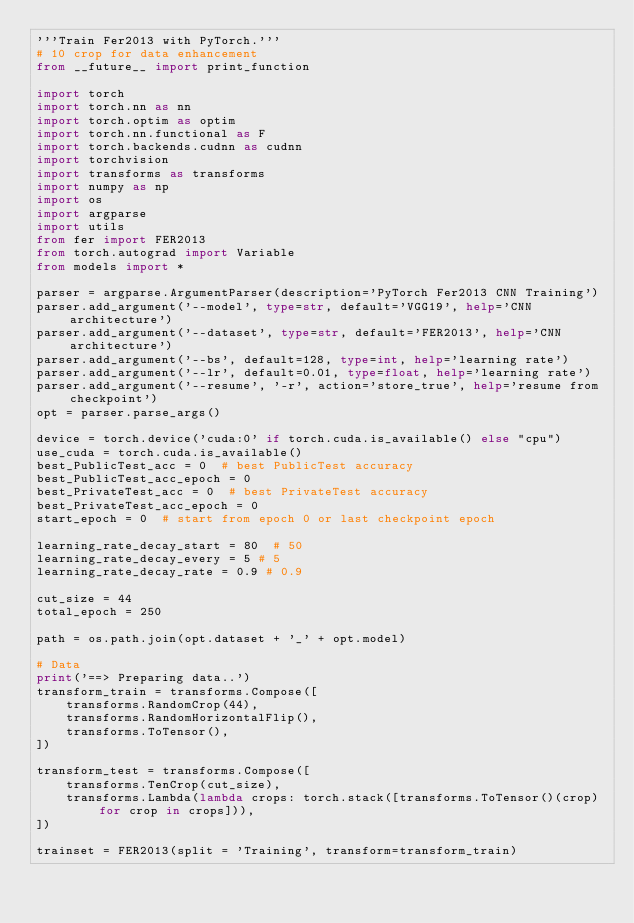<code> <loc_0><loc_0><loc_500><loc_500><_Python_>'''Train Fer2013 with PyTorch.'''
# 10 crop for data enhancement
from __future__ import print_function

import torch
import torch.nn as nn
import torch.optim as optim
import torch.nn.functional as F
import torch.backends.cudnn as cudnn
import torchvision
import transforms as transforms
import numpy as np
import os
import argparse
import utils
from fer import FER2013
from torch.autograd import Variable
from models import *

parser = argparse.ArgumentParser(description='PyTorch Fer2013 CNN Training')
parser.add_argument('--model', type=str, default='VGG19', help='CNN architecture')
parser.add_argument('--dataset', type=str, default='FER2013', help='CNN architecture')
parser.add_argument('--bs', default=128, type=int, help='learning rate')
parser.add_argument('--lr', default=0.01, type=float, help='learning rate')
parser.add_argument('--resume', '-r', action='store_true', help='resume from checkpoint')
opt = parser.parse_args()

device = torch.device('cuda:0' if torch.cuda.is_available() else "cpu")
use_cuda = torch.cuda.is_available()
best_PublicTest_acc = 0  # best PublicTest accuracy
best_PublicTest_acc_epoch = 0
best_PrivateTest_acc = 0  # best PrivateTest accuracy
best_PrivateTest_acc_epoch = 0
start_epoch = 0  # start from epoch 0 or last checkpoint epoch

learning_rate_decay_start = 80  # 50
learning_rate_decay_every = 5 # 5
learning_rate_decay_rate = 0.9 # 0.9

cut_size = 44
total_epoch = 250

path = os.path.join(opt.dataset + '_' + opt.model)

# Data
print('==> Preparing data..')
transform_train = transforms.Compose([
    transforms.RandomCrop(44),
    transforms.RandomHorizontalFlip(),
    transforms.ToTensor(),
])

transform_test = transforms.Compose([
    transforms.TenCrop(cut_size),
    transforms.Lambda(lambda crops: torch.stack([transforms.ToTensor()(crop) for crop in crops])),
])

trainset = FER2013(split = 'Training', transform=transform_train)</code> 